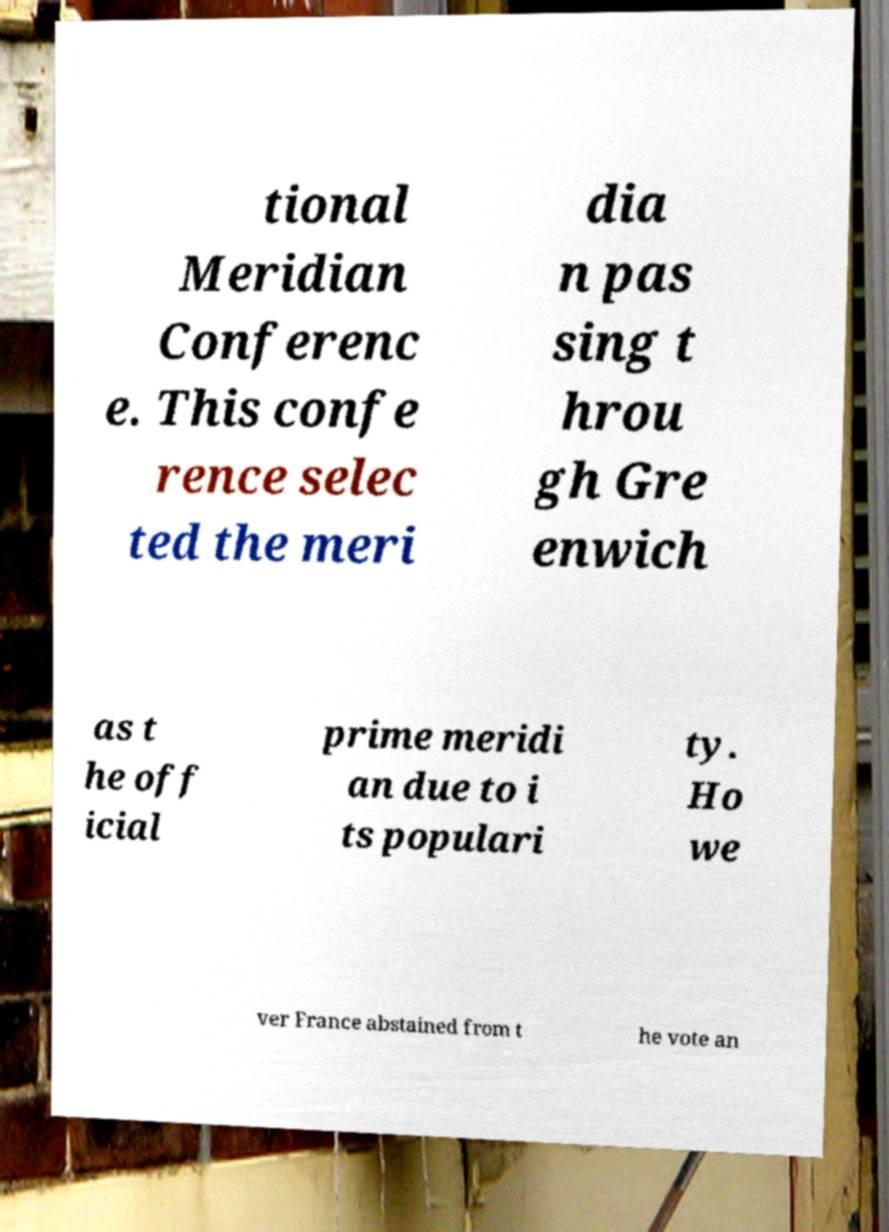Could you assist in decoding the text presented in this image and type it out clearly? tional Meridian Conferenc e. This confe rence selec ted the meri dia n pas sing t hrou gh Gre enwich as t he off icial prime meridi an due to i ts populari ty. Ho we ver France abstained from t he vote an 